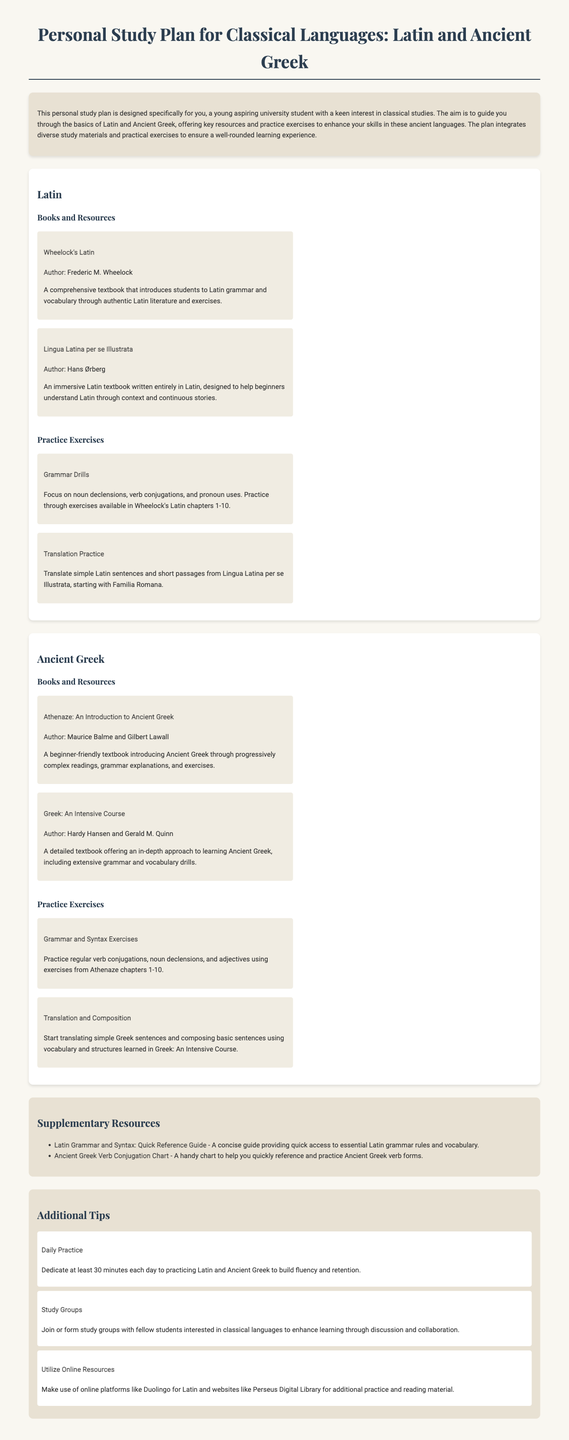What is the main aim of the personal study plan? The main aim of the study plan is to guide students through the basics of Latin and Ancient Greek, enhancing their skills with key resources and practice exercises.
Answer: To guide students through the basics of Latin and Ancient Greek Who is the author of "Wheelock's Latin"? The author's name is provided in the document as Frederic M. Wheelock.
Answer: Frederic M. Wheelock What does Athenaze introduce? The document states that Athenaze introduces Ancient Greek through progressively complex readings, grammar explanations, and exercises.
Answer: Ancient Greek What is the title of the supplementary resource for Latin grammar? The title provided for the supplementary resource is "Latin Grammar and Syntax: Quick Reference Guide."
Answer: Latin Grammar and Syntax: Quick Reference Guide How many minutes should be dedicated to daily practice? The recommendation in the tips section suggests dedicating at least 30 minutes to daily practice.
Answer: 30 minutes What kind of exercises does "Greek: An Intensive Course" include? The document mentions that this course includes extensive grammar and vocabulary drills.
Answer: Extensive grammar and vocabulary drills What is a suggested method to enhance learning according to the tips? Joining or forming study groups with fellow students is suggested for enhancing learning.
Answer: Study groups What chapters should grammar drills focus on in "Wheelock's Latin"? The grammar drills should focus on exercises available in chapters 1-10 of Wheelock's Latin.
Answer: Chapters 1-10 